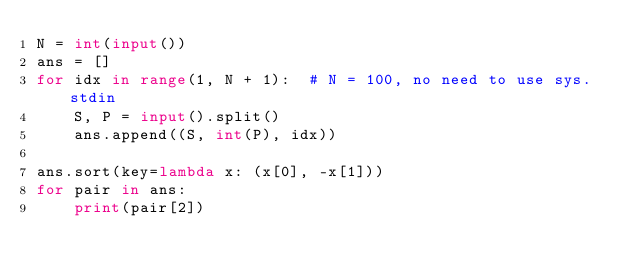<code> <loc_0><loc_0><loc_500><loc_500><_Python_>N = int(input())
ans = []
for idx in range(1, N + 1):  # N = 100, no need to use sys.stdin
    S, P = input().split()
    ans.append((S, int(P), idx))

ans.sort(key=lambda x: (x[0], -x[1]))
for pair in ans:
    print(pair[2])
</code> 